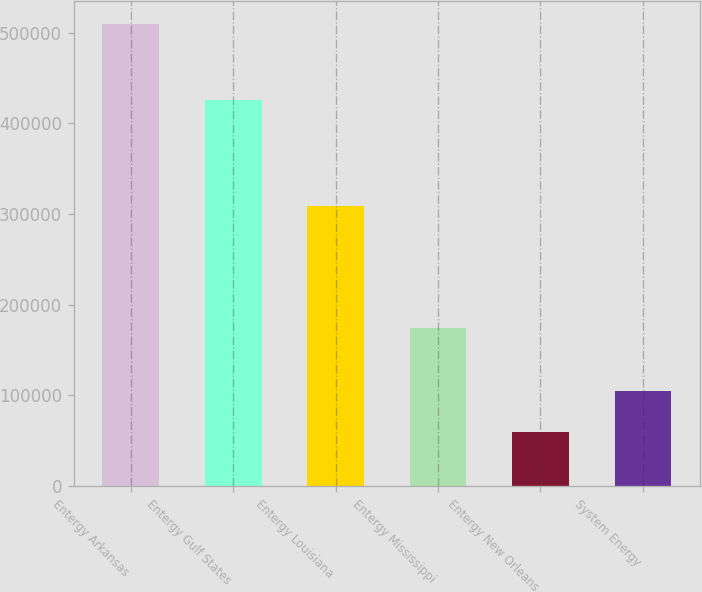Convert chart. <chart><loc_0><loc_0><loc_500><loc_500><bar_chart><fcel>Entergy Arkansas<fcel>Entergy Gulf States<fcel>Entergy Louisiana<fcel>Entergy Mississippi<fcel>Entergy New Orleans<fcel>System Energy<nl><fcel>509382<fcel>426320<fcel>309066<fcel>174245<fcel>59610<fcel>104587<nl></chart> 